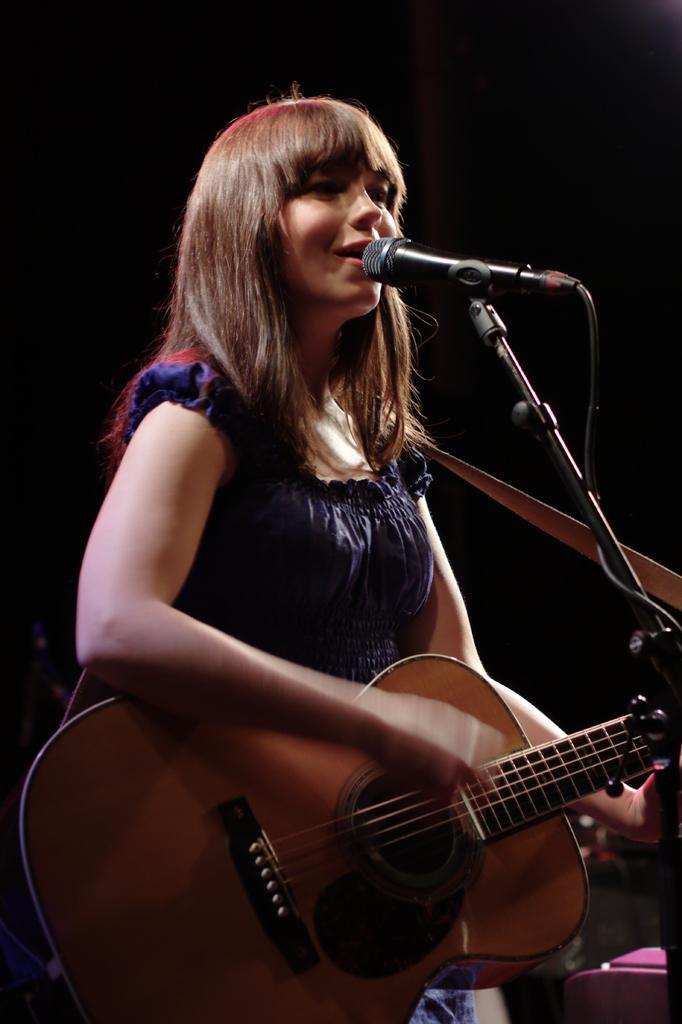What is the woman doing in the image? The woman is standing, playing a guitar, and singing a song. What instrument is the woman playing in the image? The woman is playing a guitar in the image. What activity is the woman engaged in while playing the guitar? The woman is singing a song while playing the guitar. What type of scent can be detected from the woman's neck in the image? There is no information about the woman's scent or neck in the image, so it cannot be determined. 